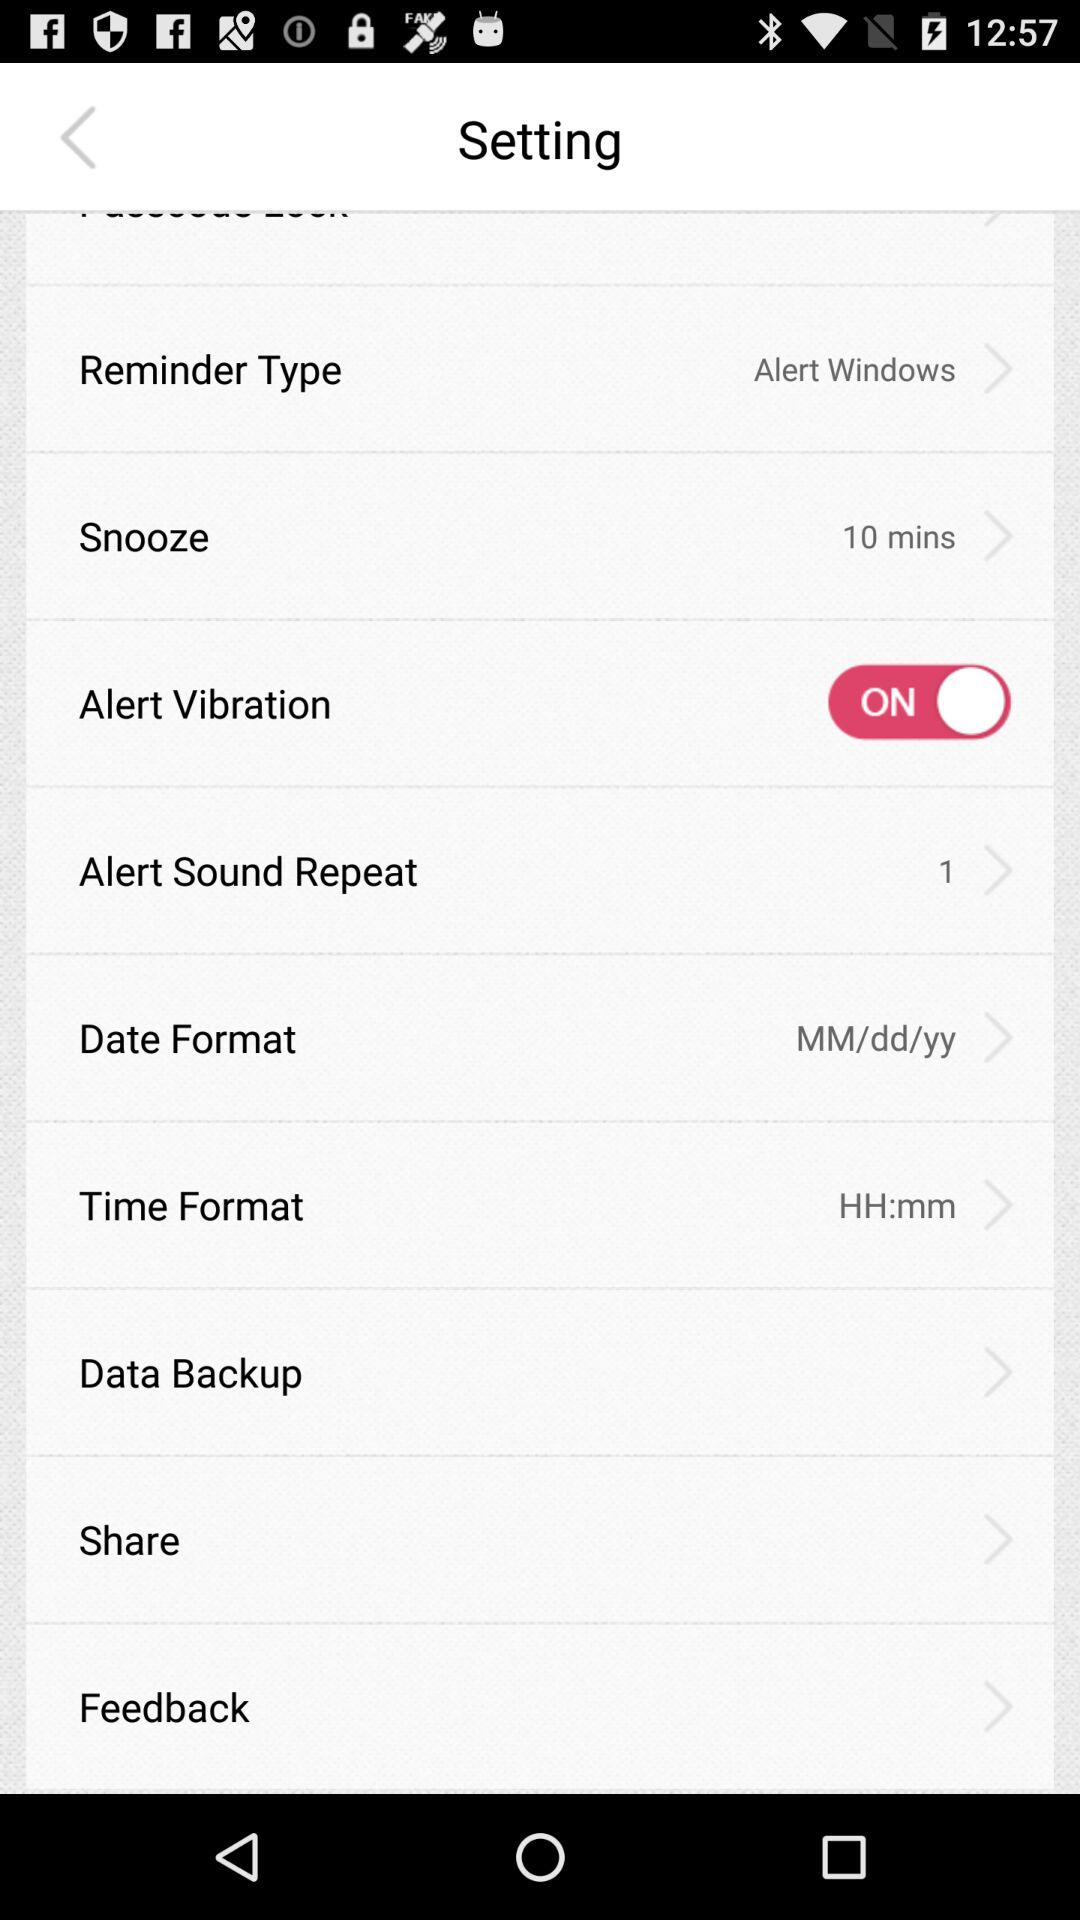What is the "Snooze" time? The "Snooze" time is 10 minutes. 